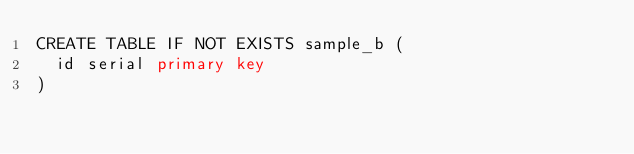Convert code to text. <code><loc_0><loc_0><loc_500><loc_500><_SQL_>CREATE TABLE IF NOT EXISTS sample_b (
  id serial primary key
)</code> 